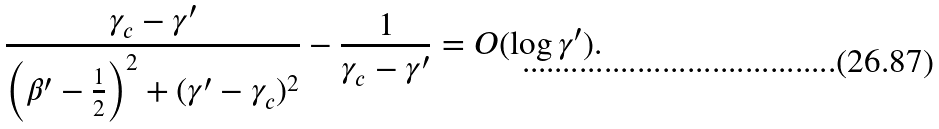<formula> <loc_0><loc_0><loc_500><loc_500>\frac { \gamma _ { c } - \gamma ^ { \prime } } { \left ( \beta ^ { \prime } - \frac { 1 } { 2 } \right ) ^ { 2 } + ( \gamma ^ { \prime } - \gamma _ { c } ) ^ { 2 } } - \frac { 1 } { \gamma _ { c } - \gamma ^ { \prime } } = O ( \log \gamma ^ { \prime } ) .</formula> 